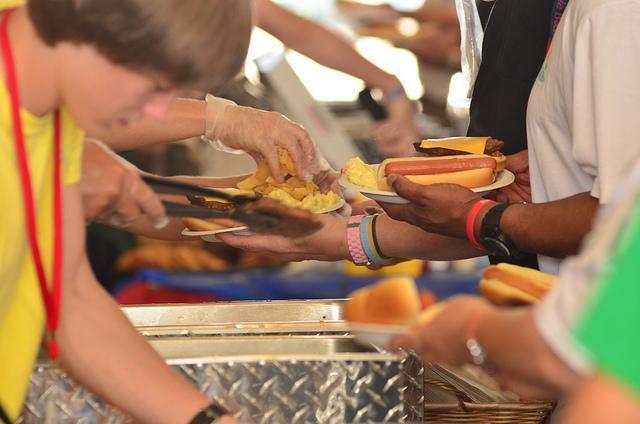How many hot dogs are in the photo?
Give a very brief answer. 2. How many people are in the picture?
Give a very brief answer. 8. 